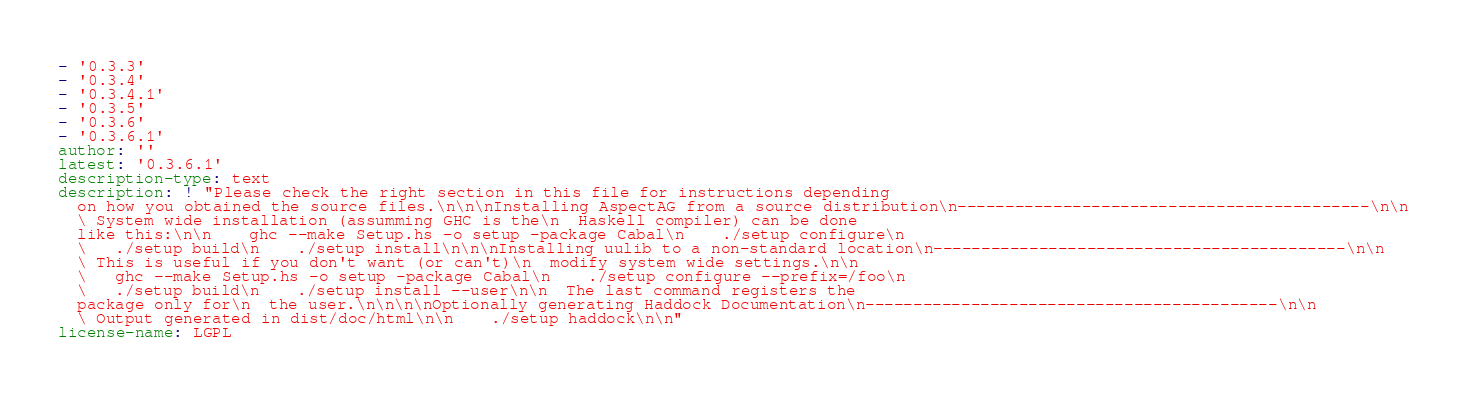<code> <loc_0><loc_0><loc_500><loc_500><_YAML_>- '0.3.3'
- '0.3.4'
- '0.3.4.1'
- '0.3.5'
- '0.3.6'
- '0.3.6.1'
author: ''
latest: '0.3.6.1'
description-type: text
description: ! "Please check the right section in this file for instructions depending
  on how you obtained the source files.\n\n\nInstalling AspectAG from a source distribution\n-------------------------------------------\n\n
  \ System wide installation (assumming GHC is the\n  Haskell compiler) can be done
  like this:\n\n    ghc --make Setup.hs -o setup -package Cabal\n    ./setup configure\n
  \   ./setup build\n    ./setup install\n\n\nInstalling uulib to a non-standard location\n-------------------------------------------\n\n
  \ This is useful if you don't want (or can't)\n  modify system wide settings.\n\n
  \   ghc --make Setup.hs -o setup -package Cabal\n    ./setup configure --prefix=/foo\n
  \   ./setup build\n    ./setup install --user\n\n  The last command registers the
  package only for\n  the user.\n\n\n\nOptionally generating Haddock Documentation\n-------------------------------------------\n\n
  \ Output generated in dist/doc/html\n\n    ./setup haddock\n\n"
license-name: LGPL
</code> 